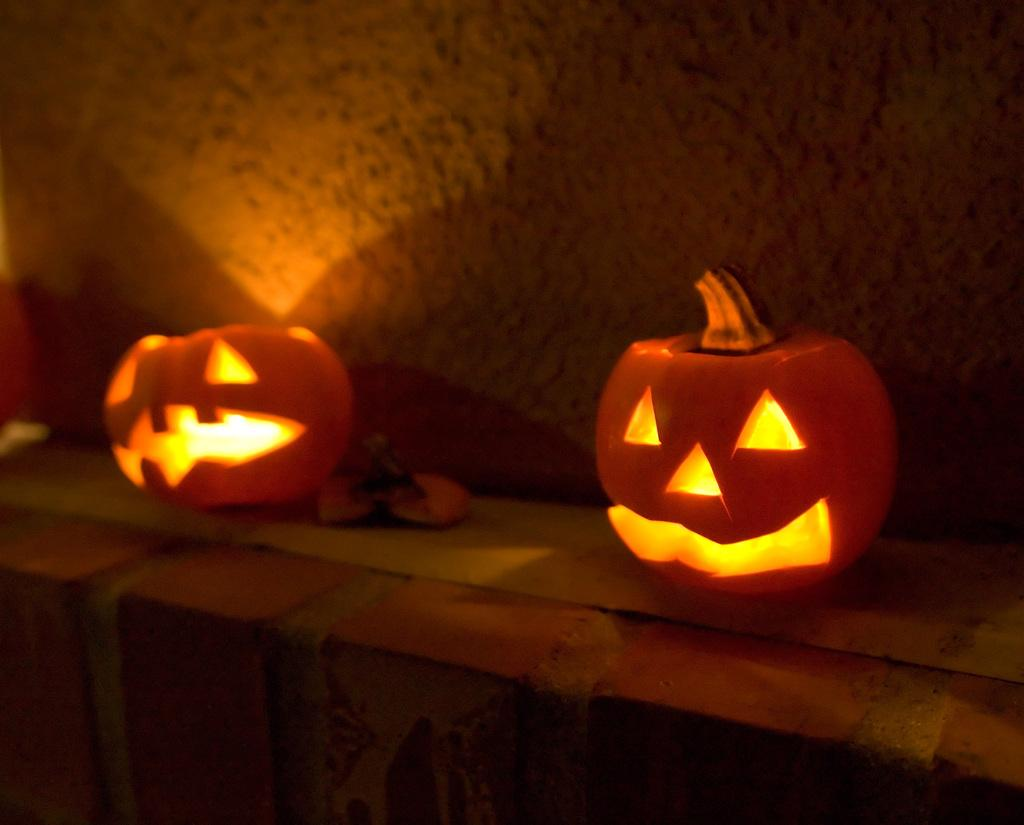What objects are featured in the image with lights? There are pumpkins with lights in the image. Where are the pumpkins located? The pumpkins are on a wall. What can be seen in the background of the image? There is a wall in the background of the image. What type of needle is being used to sew the circle in the image? There is no needle or circle present in the image; it features pumpkins with lights on a wall. 